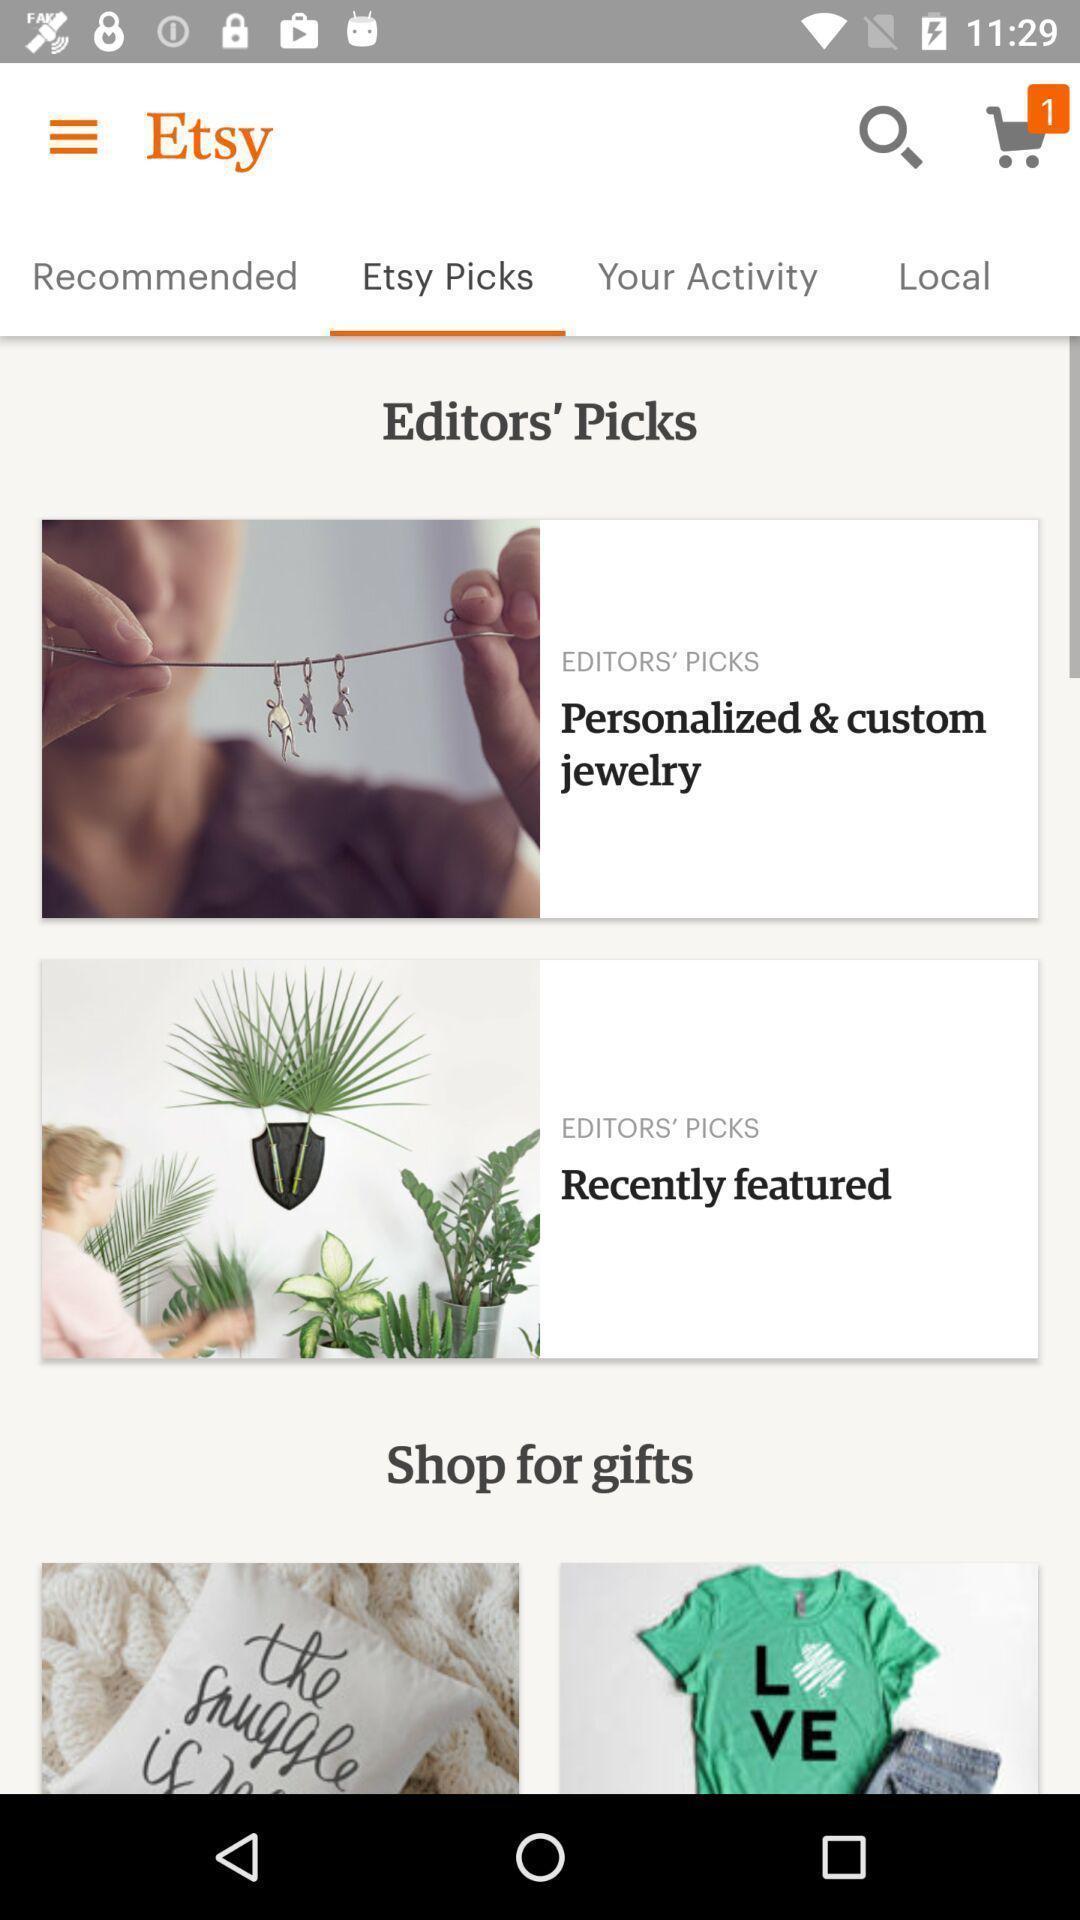Explain what's happening in this screen capture. Screen displaying list of items on a shopping app. 